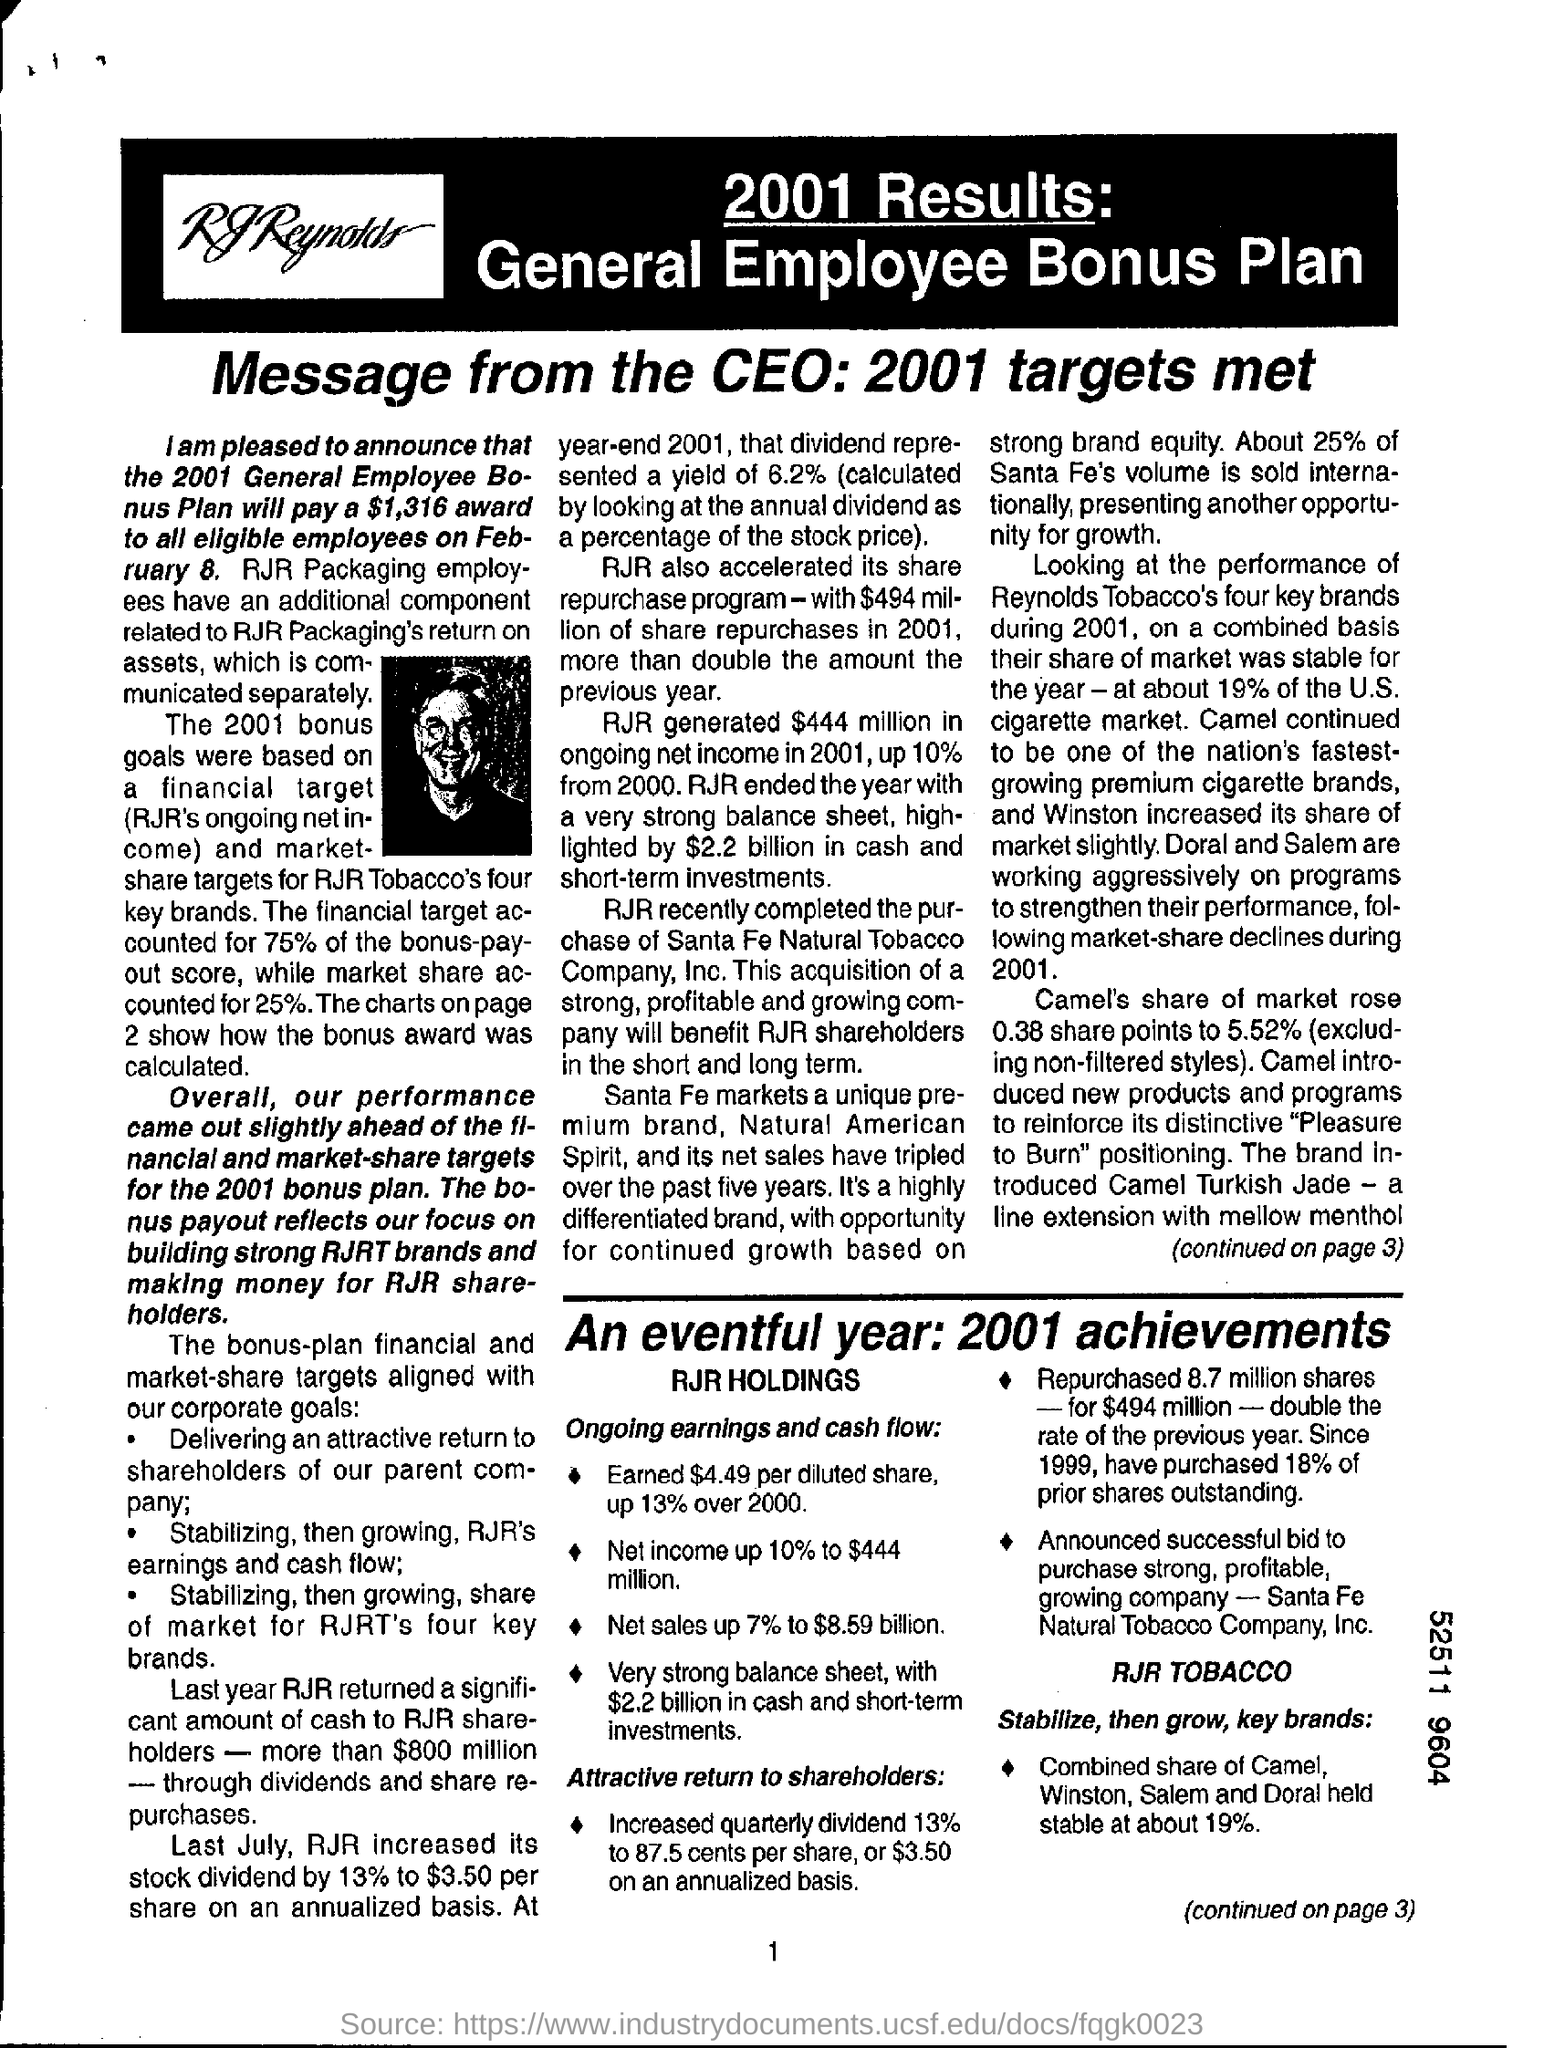Whom is this message from ?
Provide a succinct answer. Ceo. 